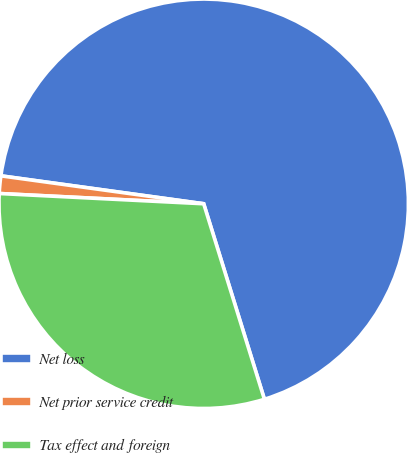Convert chart. <chart><loc_0><loc_0><loc_500><loc_500><pie_chart><fcel>Net loss<fcel>Net prior service credit<fcel>Tax effect and foreign<nl><fcel>68.03%<fcel>1.38%<fcel>30.59%<nl></chart> 